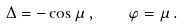Convert formula to latex. <formula><loc_0><loc_0><loc_500><loc_500>\Delta = - \cos \mu \, , \quad \varphi = \mu \, .</formula> 